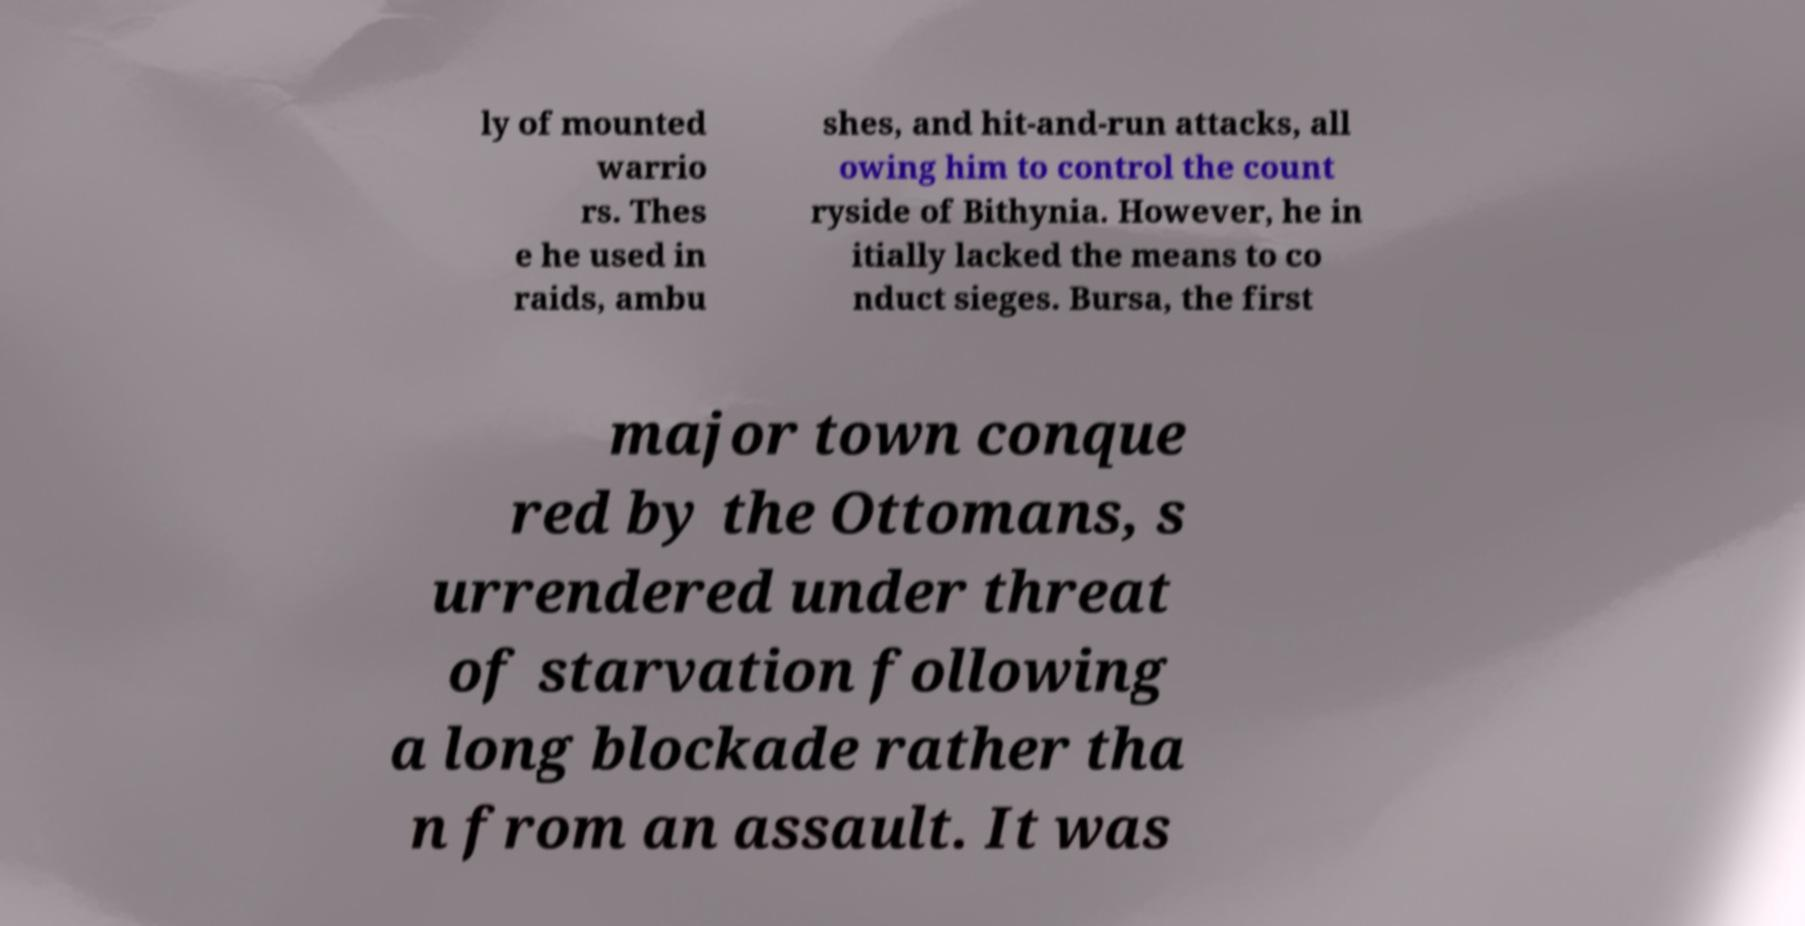Can you read and provide the text displayed in the image?This photo seems to have some interesting text. Can you extract and type it out for me? ly of mounted warrio rs. Thes e he used in raids, ambu shes, and hit-and-run attacks, all owing him to control the count ryside of Bithynia. However, he in itially lacked the means to co nduct sieges. Bursa, the first major town conque red by the Ottomans, s urrendered under threat of starvation following a long blockade rather tha n from an assault. It was 